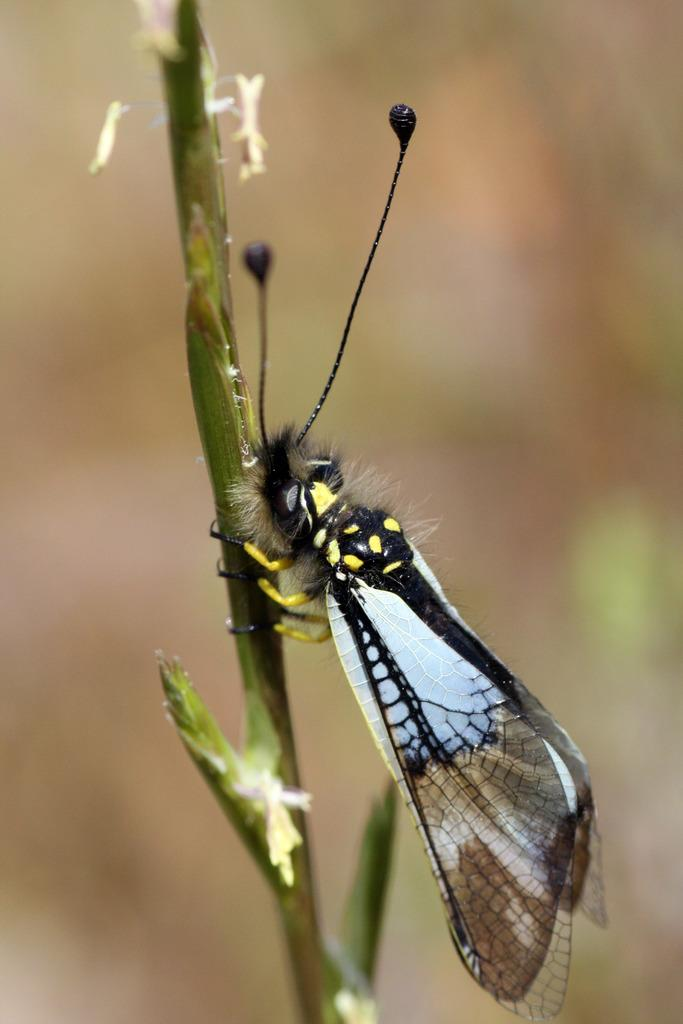What is the main subject of the image? There is a butterfly in the image. Where is the butterfly located in relation to the stem? The butterfly is on a stem. How are the butterfly and stem positioned in the image? The butterfly and stem are in the center of the image. What type of sponge is being used to clean the butterfly's wings in the image? There is no sponge or cleaning activity depicted in the image; it simply shows a butterfly on a stem. 